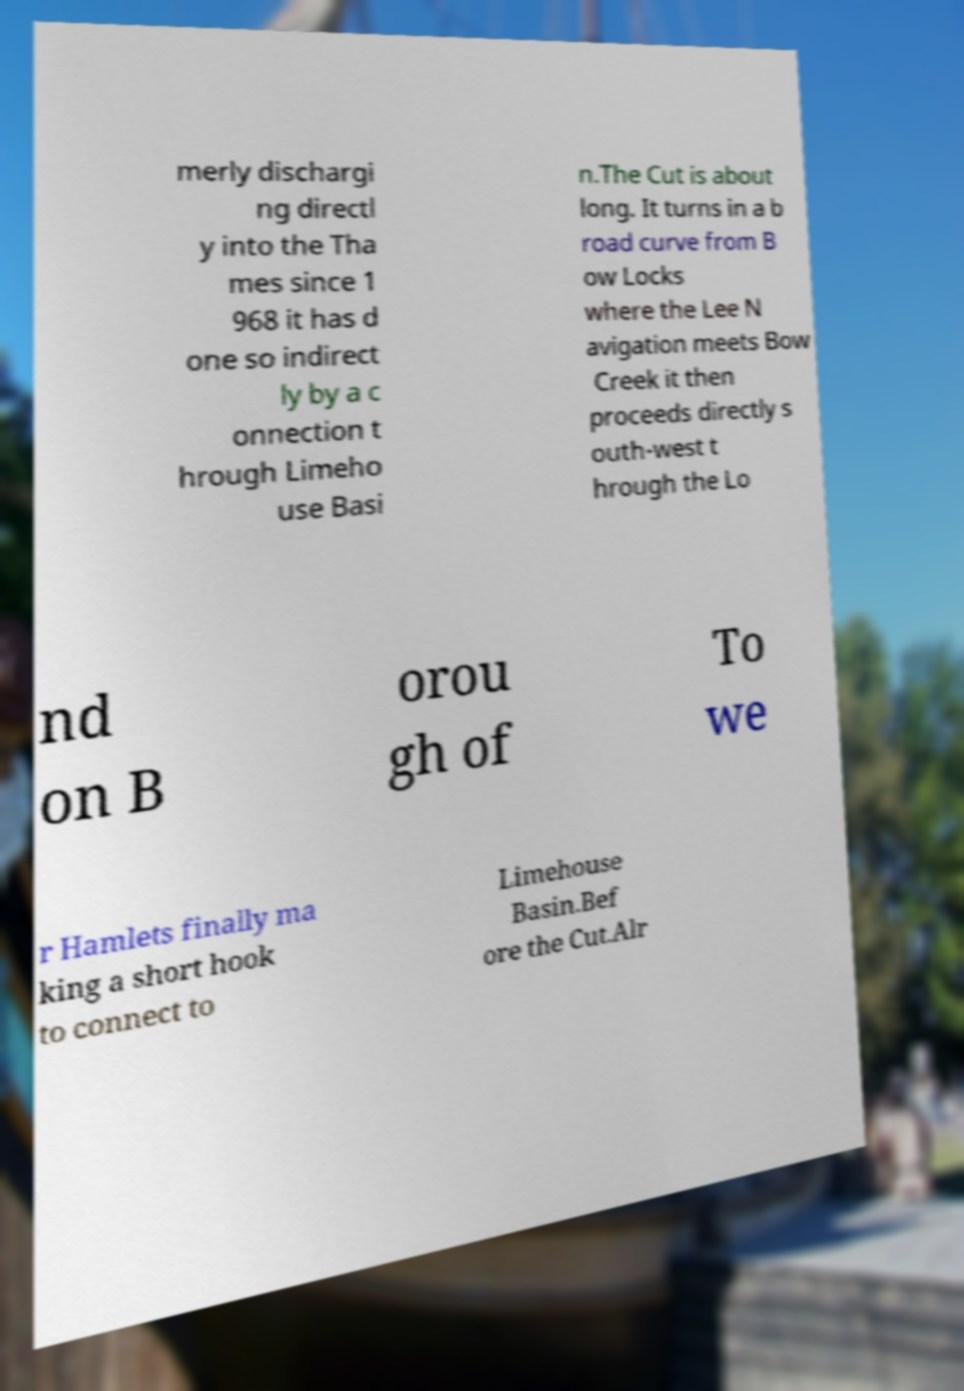Can you accurately transcribe the text from the provided image for me? merly dischargi ng directl y into the Tha mes since 1 968 it has d one so indirect ly by a c onnection t hrough Limeho use Basi n.The Cut is about long. It turns in a b road curve from B ow Locks where the Lee N avigation meets Bow Creek it then proceeds directly s outh-west t hrough the Lo nd on B orou gh of To we r Hamlets finally ma king a short hook to connect to Limehouse Basin.Bef ore the Cut.Alr 